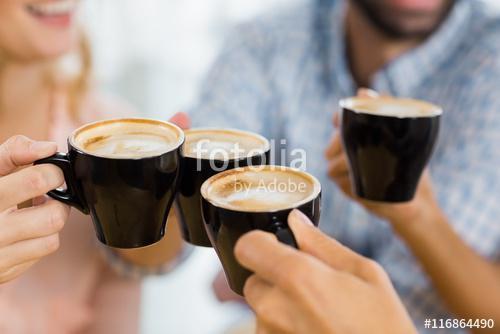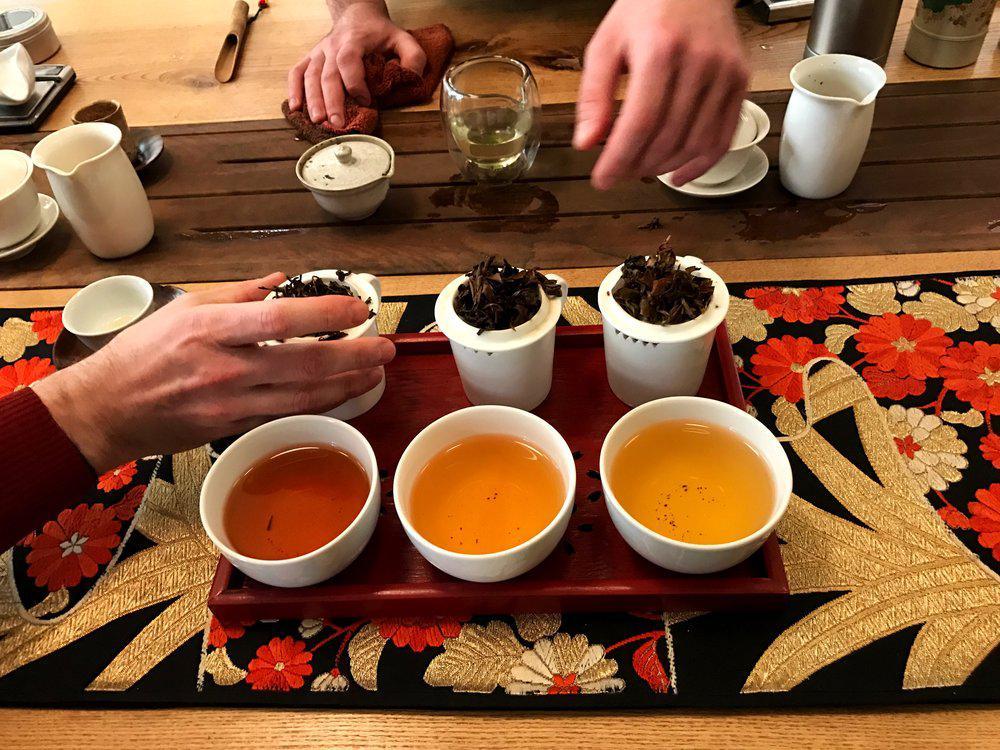The first image is the image on the left, the second image is the image on the right. For the images displayed, is the sentence "There are exactly four cups." factually correct? Answer yes or no. No. 